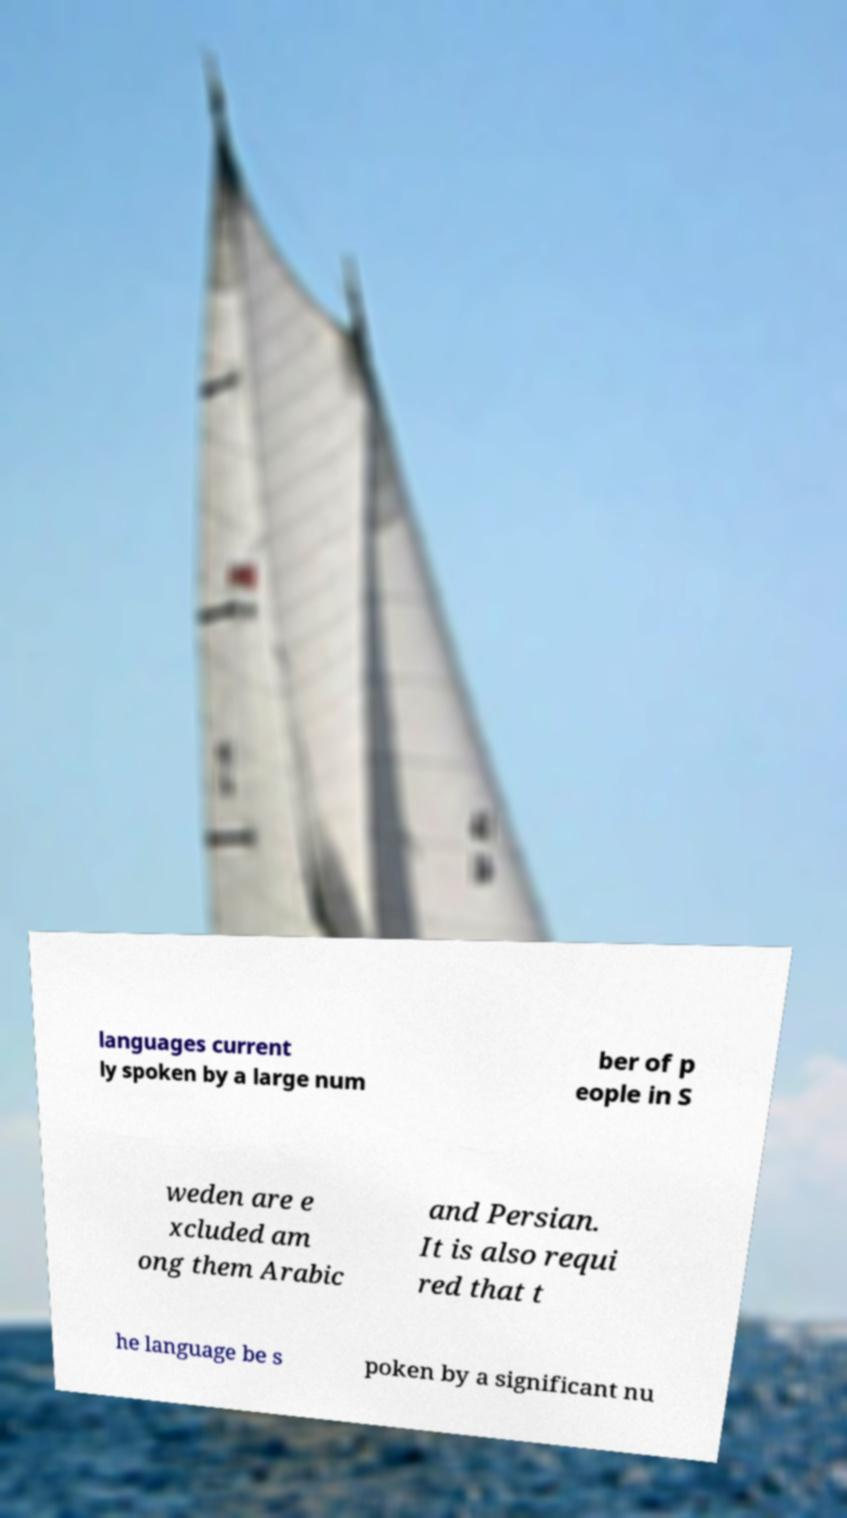There's text embedded in this image that I need extracted. Can you transcribe it verbatim? languages current ly spoken by a large num ber of p eople in S weden are e xcluded am ong them Arabic and Persian. It is also requi red that t he language be s poken by a significant nu 